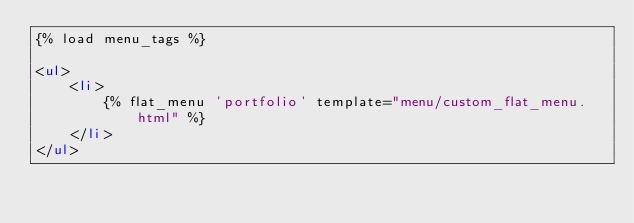Convert code to text. <code><loc_0><loc_0><loc_500><loc_500><_HTML_>{% load menu_tags %}

<ul>
    <li>
        {% flat_menu 'portfolio' template="menu/custom_flat_menu.html" %}
    </li>
</ul>

</code> 